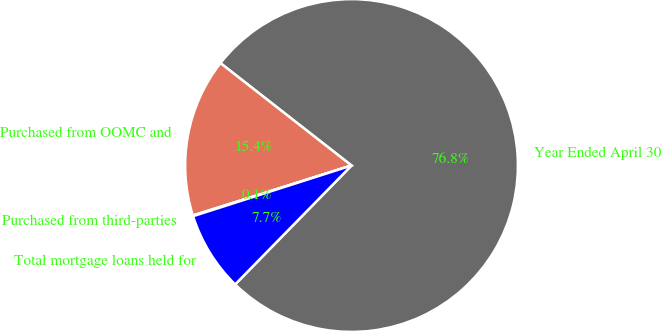Convert chart to OTSL. <chart><loc_0><loc_0><loc_500><loc_500><pie_chart><fcel>Year Ended April 30<fcel>Purchased from OOMC and<fcel>Purchased from third-parties<fcel>Total mortgage loans held for<nl><fcel>76.77%<fcel>15.41%<fcel>0.07%<fcel>7.74%<nl></chart> 